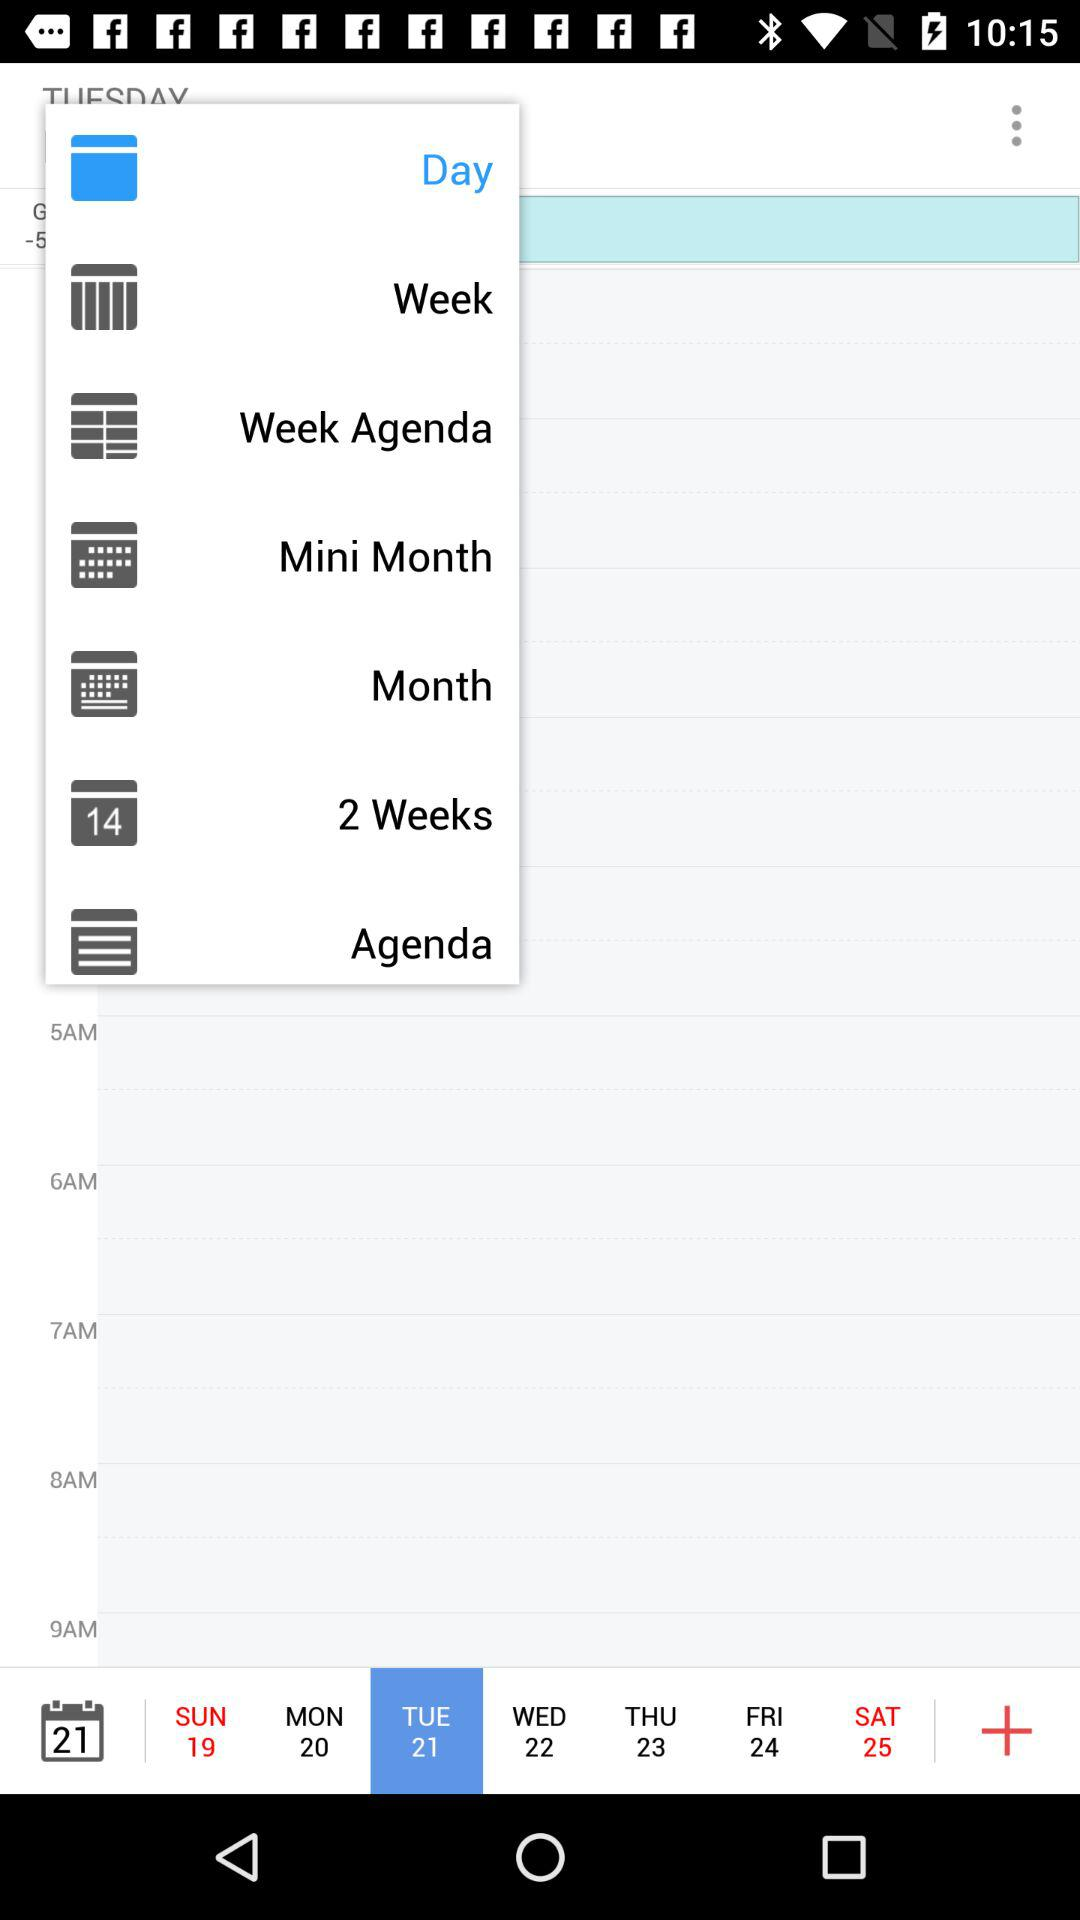Which option has been selected? The selected options are "Day" and "Tue 21". 